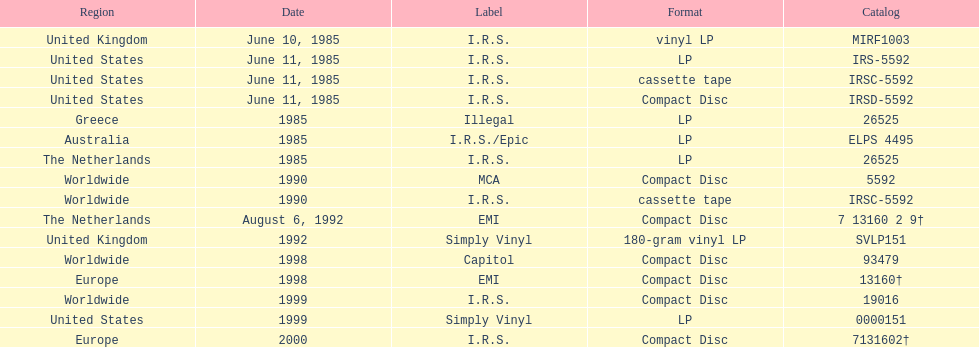How many times was the album released? 13. 